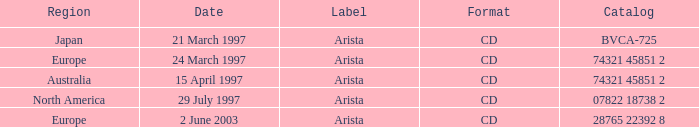What Format has the Region of Europe and a Catalog of 74321 45851 2? CD. 